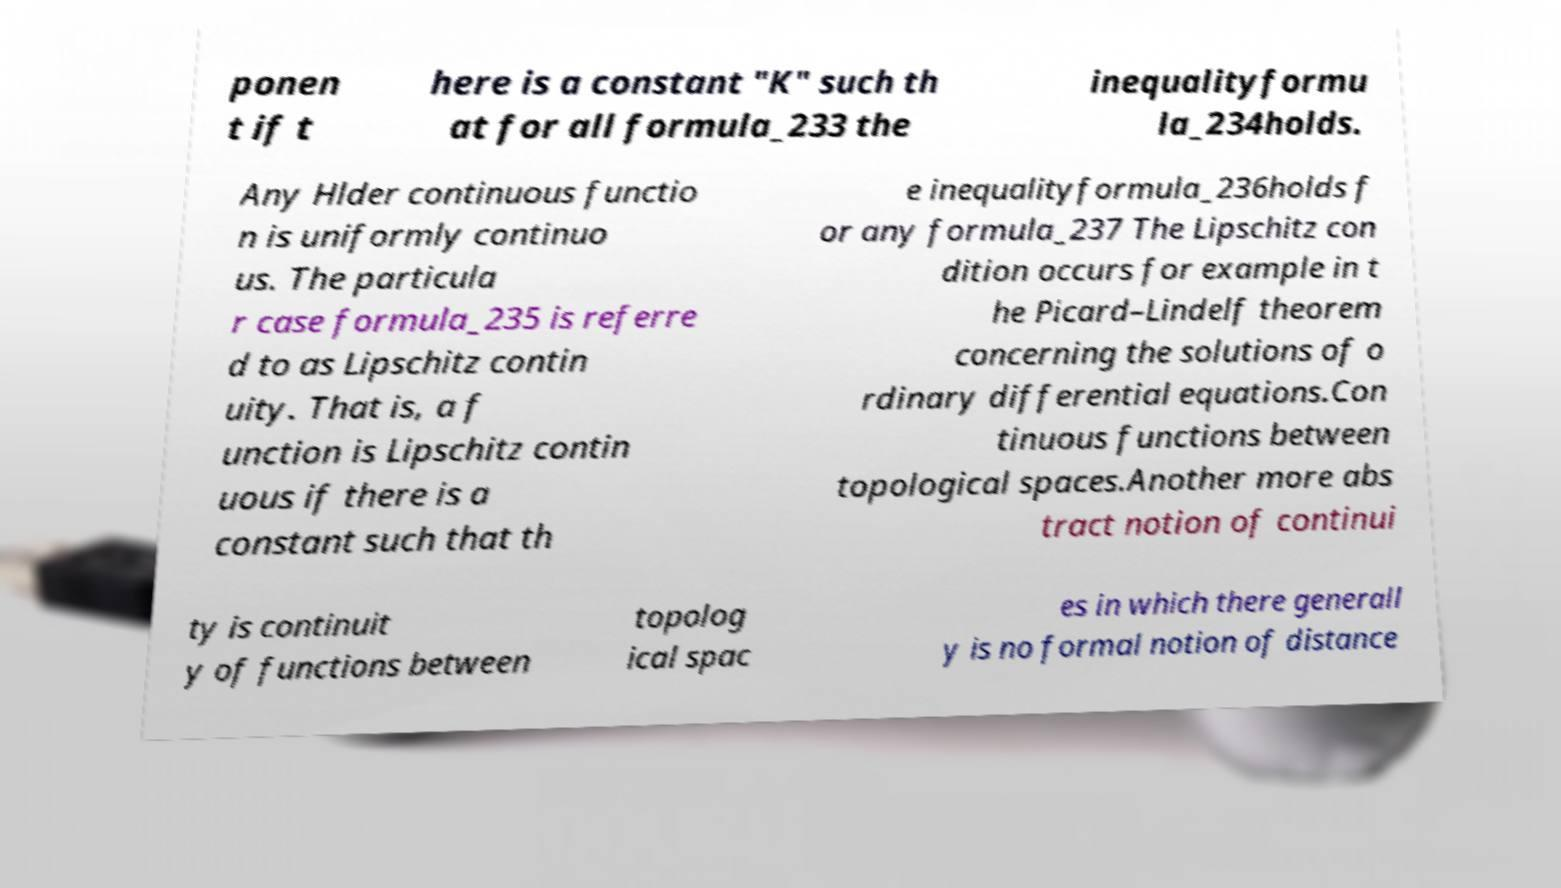Could you assist in decoding the text presented in this image and type it out clearly? ponen t if t here is a constant "K" such th at for all formula_233 the inequalityformu la_234holds. Any Hlder continuous functio n is uniformly continuo us. The particula r case formula_235 is referre d to as Lipschitz contin uity. That is, a f unction is Lipschitz contin uous if there is a constant such that th e inequalityformula_236holds f or any formula_237 The Lipschitz con dition occurs for example in t he Picard–Lindelf theorem concerning the solutions of o rdinary differential equations.Con tinuous functions between topological spaces.Another more abs tract notion of continui ty is continuit y of functions between topolog ical spac es in which there generall y is no formal notion of distance 